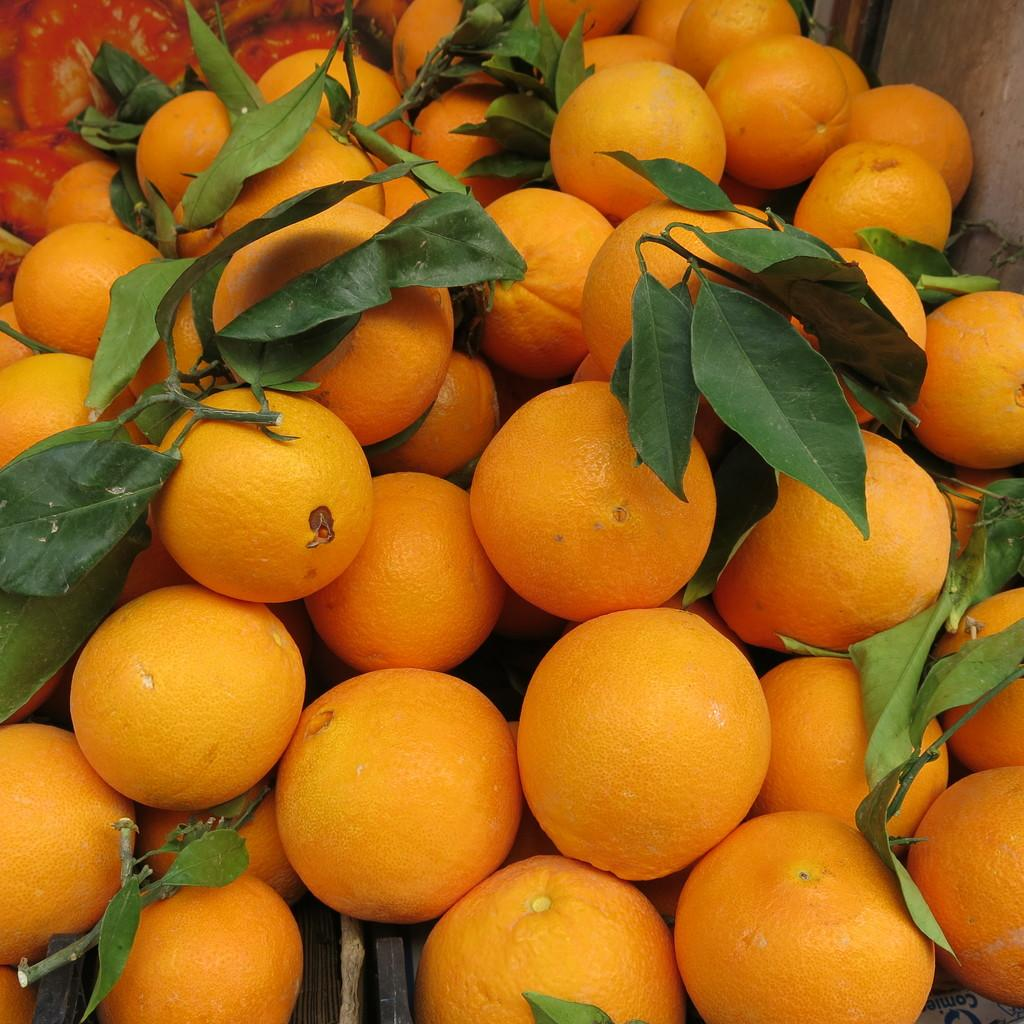What type of fruit is present in the image? There are many oranges in the image. Are there any other plant-related items visible in the image? Yes, there are a few leaves in the image. Can you see the friend wearing a mask in the image? There is no friend or mask present in the image; it only features oranges and leaves. What fraction of the image is occupied by oranges? It is not possible to determine the fraction of the image occupied by oranges based on the provided facts. 